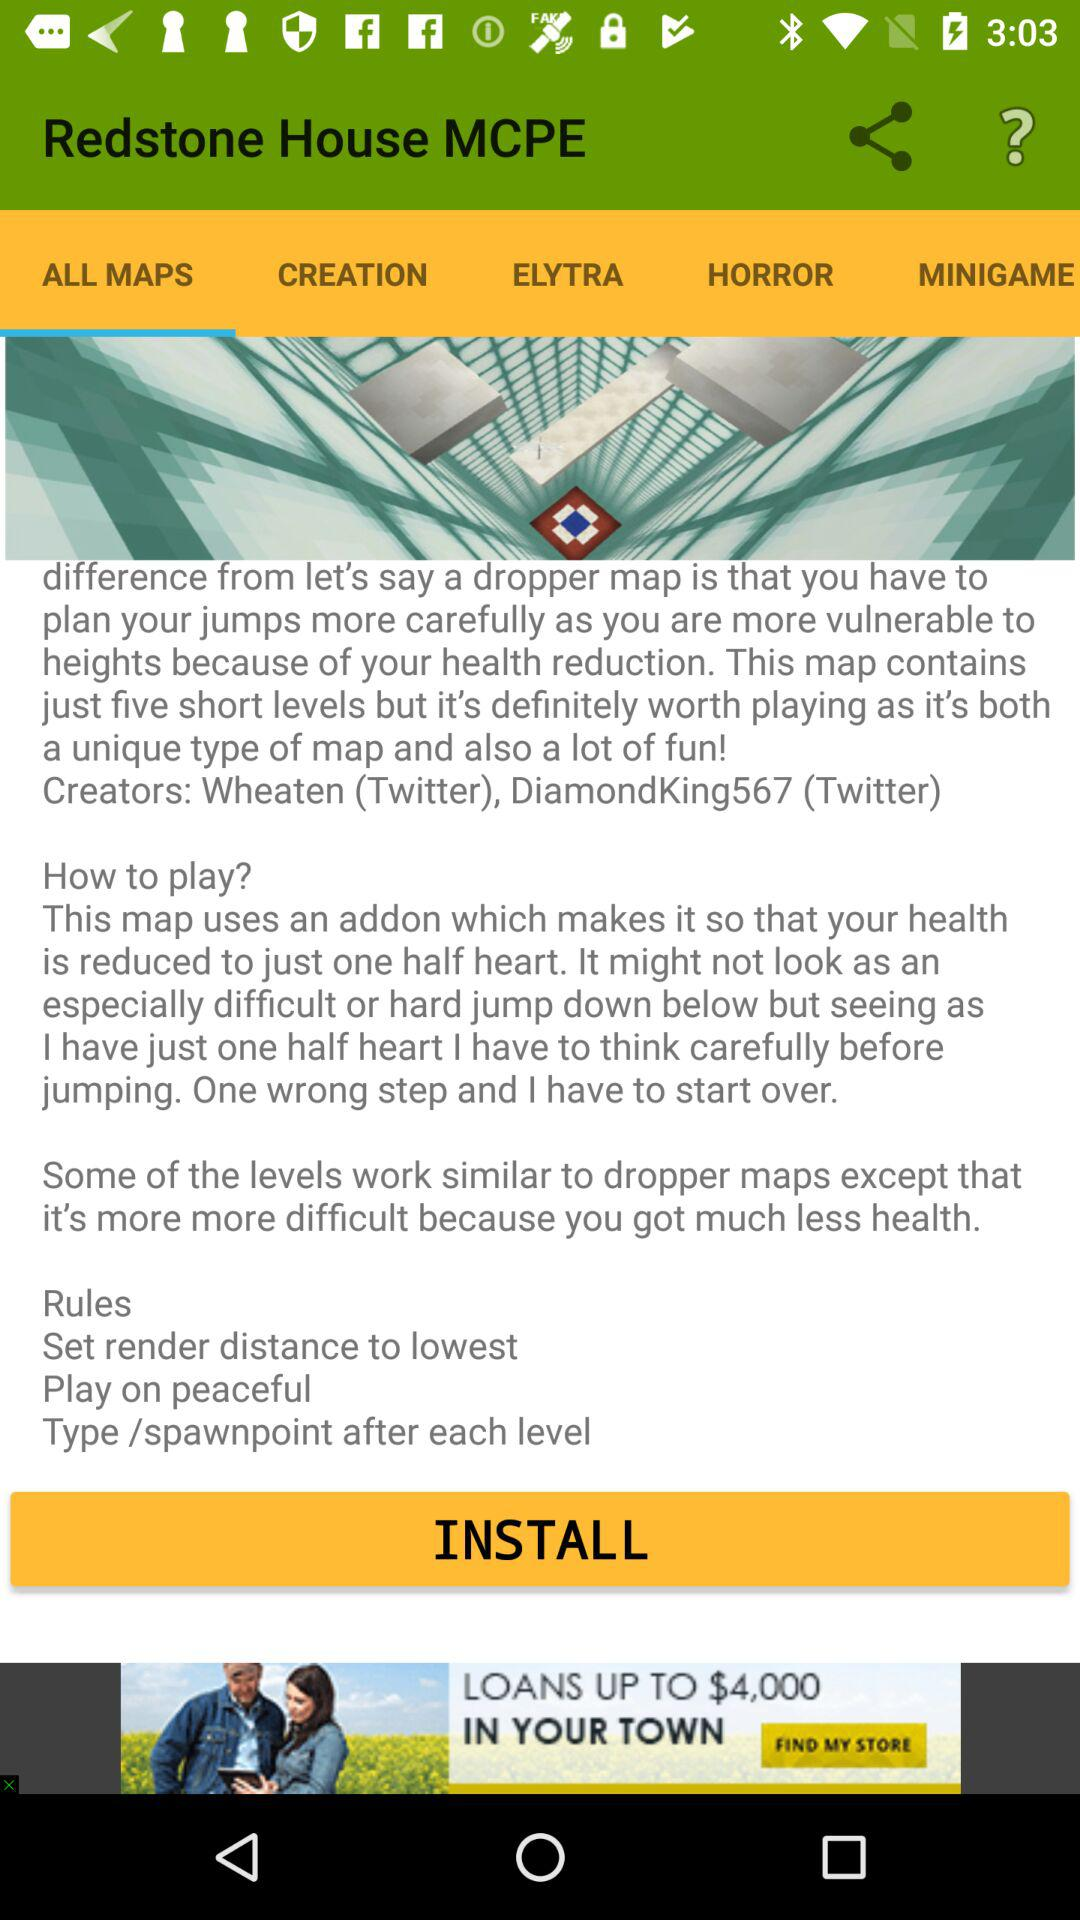How many levels does the map have?
Answer the question using a single word or phrase. 5 